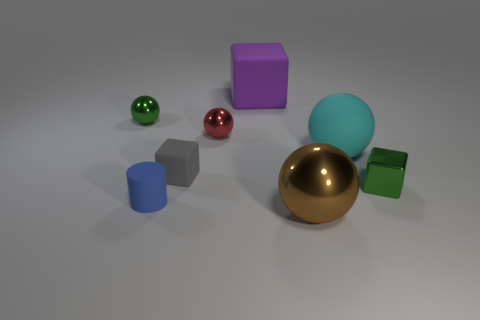Are there any red objects made of the same material as the big cyan ball?
Your response must be concise. No. Does the tiny blue thing have the same material as the small gray block?
Your answer should be compact. Yes. What number of cylinders are tiny red objects or green objects?
Offer a very short reply. 0. There is a ball that is made of the same material as the large purple thing; what is its color?
Give a very brief answer. Cyan. Are there fewer large brown metal spheres than shiny balls?
Offer a very short reply. Yes. There is a green thing that is on the right side of the big rubber ball; is its shape the same as the tiny green metal object that is left of the tiny red metal object?
Ensure brevity in your answer.  No. What number of objects are large brown shiny cylinders or rubber cubes?
Give a very brief answer. 2. What is the color of the cube that is the same size as the gray rubber thing?
Provide a short and direct response. Green. How many tiny matte things are in front of the green metallic thing that is to the right of the tiny blue rubber object?
Your response must be concise. 1. What number of cubes are both left of the green metallic block and in front of the big cyan matte sphere?
Offer a terse response. 1. 